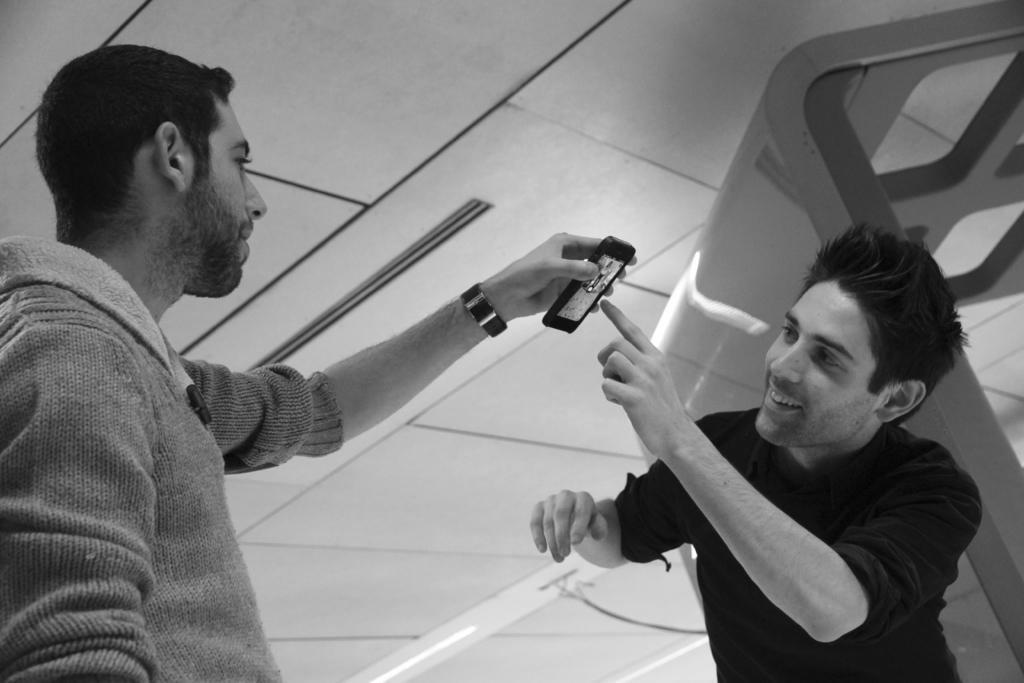Can you describe this image briefly? In this image we can see a black and white picture of two persons. One person is holding a mobile in his hand. One person is wearing a black dress. In the background, we can see a metal frame and some lights. 